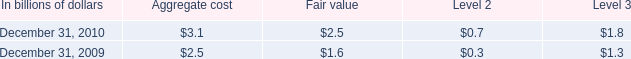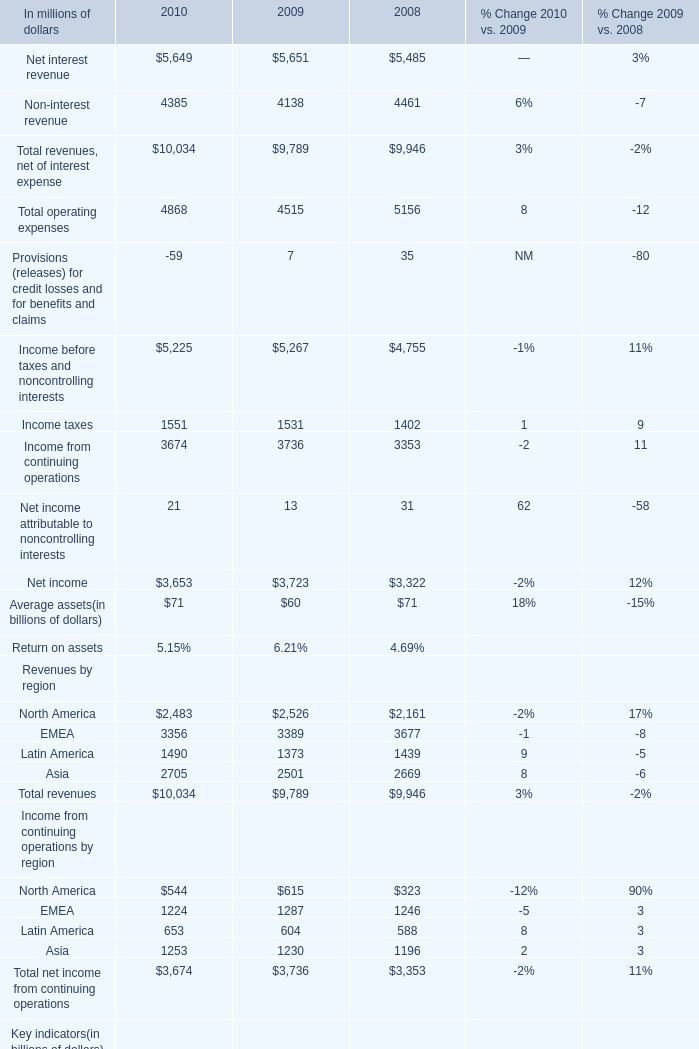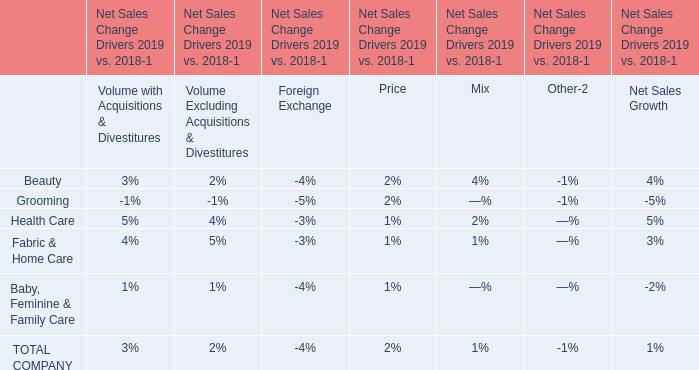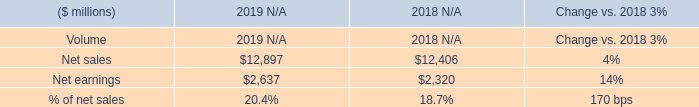what was the growth rate of the loans held-for-sale that are carried at locom from 2009 to 2010 
Computations: ((2.5 / 1.6) / 1.6)
Answer: 0.97656. 